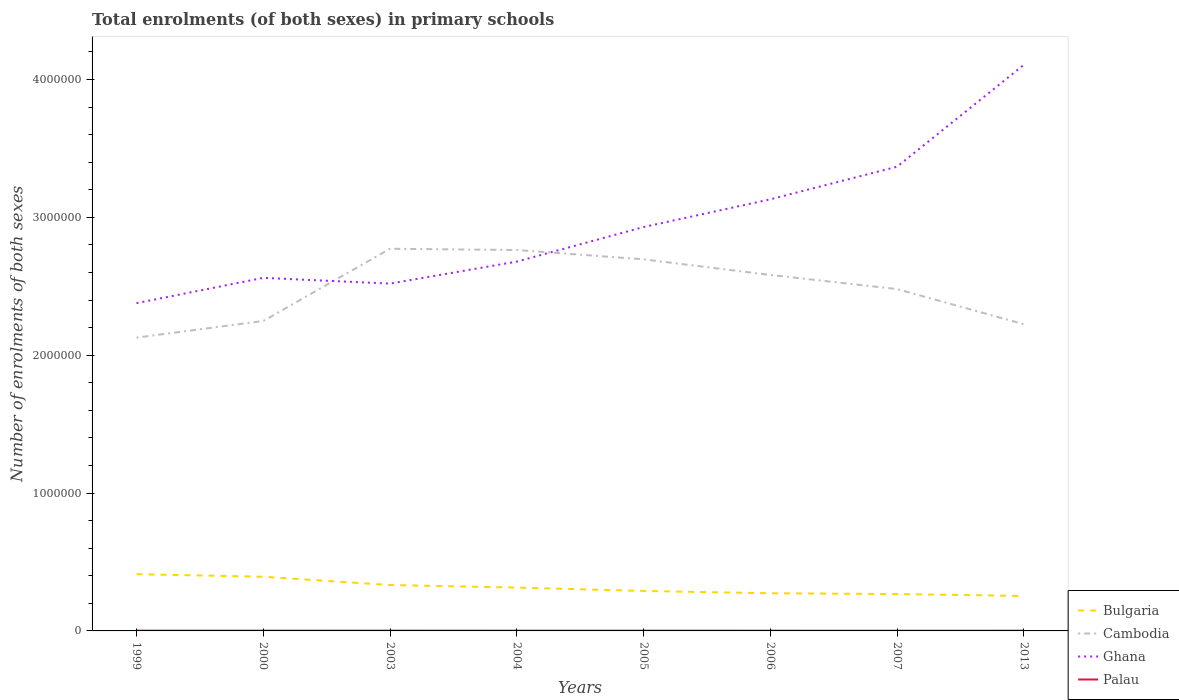Does the line corresponding to Cambodia intersect with the line corresponding to Palau?
Your answer should be very brief. No. Across all years, what is the maximum number of enrolments in primary schools in Ghana?
Make the answer very short. 2.38e+06. What is the total number of enrolments in primary schools in Cambodia in the graph?
Provide a succinct answer. 2.16e+05. What is the difference between the highest and the second highest number of enrolments in primary schools in Bulgaria?
Make the answer very short. 1.58e+05. Is the number of enrolments in primary schools in Cambodia strictly greater than the number of enrolments in primary schools in Bulgaria over the years?
Give a very brief answer. No. How many years are there in the graph?
Your response must be concise. 8. What is the difference between two consecutive major ticks on the Y-axis?
Offer a very short reply. 1.00e+06. Are the values on the major ticks of Y-axis written in scientific E-notation?
Give a very brief answer. No. What is the title of the graph?
Your answer should be compact. Total enrolments (of both sexes) in primary schools. What is the label or title of the Y-axis?
Your answer should be very brief. Number of enrolments of both sexes. What is the Number of enrolments of both sexes of Bulgaria in 1999?
Ensure brevity in your answer.  4.12e+05. What is the Number of enrolments of both sexes of Cambodia in 1999?
Your answer should be very brief. 2.13e+06. What is the Number of enrolments of both sexes in Ghana in 1999?
Your answer should be compact. 2.38e+06. What is the Number of enrolments of both sexes in Palau in 1999?
Give a very brief answer. 1901. What is the Number of enrolments of both sexes of Bulgaria in 2000?
Ensure brevity in your answer.  3.93e+05. What is the Number of enrolments of both sexes of Cambodia in 2000?
Offer a very short reply. 2.25e+06. What is the Number of enrolments of both sexes of Ghana in 2000?
Your response must be concise. 2.56e+06. What is the Number of enrolments of both sexes of Palau in 2000?
Your answer should be compact. 1942. What is the Number of enrolments of both sexes of Bulgaria in 2003?
Make the answer very short. 3.33e+05. What is the Number of enrolments of both sexes in Cambodia in 2003?
Give a very brief answer. 2.77e+06. What is the Number of enrolments of both sexes in Ghana in 2003?
Keep it short and to the point. 2.52e+06. What is the Number of enrolments of both sexes of Palau in 2003?
Provide a succinct answer. 1985. What is the Number of enrolments of both sexes in Bulgaria in 2004?
Keep it short and to the point. 3.14e+05. What is the Number of enrolments of both sexes of Cambodia in 2004?
Keep it short and to the point. 2.76e+06. What is the Number of enrolments of both sexes of Ghana in 2004?
Ensure brevity in your answer.  2.68e+06. What is the Number of enrolments of both sexes in Palau in 2004?
Provide a short and direct response. 1855. What is the Number of enrolments of both sexes of Bulgaria in 2005?
Provide a succinct answer. 2.90e+05. What is the Number of enrolments of both sexes of Cambodia in 2005?
Make the answer very short. 2.70e+06. What is the Number of enrolments of both sexes in Ghana in 2005?
Ensure brevity in your answer.  2.93e+06. What is the Number of enrolments of both sexes in Palau in 2005?
Make the answer very short. 1805. What is the Number of enrolments of both sexes of Bulgaria in 2006?
Your response must be concise. 2.73e+05. What is the Number of enrolments of both sexes of Cambodia in 2006?
Ensure brevity in your answer.  2.58e+06. What is the Number of enrolments of both sexes in Ghana in 2006?
Provide a short and direct response. 3.13e+06. What is the Number of enrolments of both sexes in Palau in 2006?
Your answer should be very brief. 1657. What is the Number of enrolments of both sexes of Bulgaria in 2007?
Your response must be concise. 2.68e+05. What is the Number of enrolments of both sexes in Cambodia in 2007?
Your answer should be compact. 2.48e+06. What is the Number of enrolments of both sexes of Ghana in 2007?
Your answer should be very brief. 3.37e+06. What is the Number of enrolments of both sexes of Palau in 2007?
Give a very brief answer. 1544. What is the Number of enrolments of both sexes in Bulgaria in 2013?
Ensure brevity in your answer.  2.54e+05. What is the Number of enrolments of both sexes of Cambodia in 2013?
Your answer should be compact. 2.22e+06. What is the Number of enrolments of both sexes in Ghana in 2013?
Your answer should be compact. 4.11e+06. What is the Number of enrolments of both sexes of Palau in 2013?
Your answer should be very brief. 1654. Across all years, what is the maximum Number of enrolments of both sexes in Bulgaria?
Provide a succinct answer. 4.12e+05. Across all years, what is the maximum Number of enrolments of both sexes in Cambodia?
Offer a very short reply. 2.77e+06. Across all years, what is the maximum Number of enrolments of both sexes of Ghana?
Your answer should be compact. 4.11e+06. Across all years, what is the maximum Number of enrolments of both sexes in Palau?
Offer a very short reply. 1985. Across all years, what is the minimum Number of enrolments of both sexes in Bulgaria?
Give a very brief answer. 2.54e+05. Across all years, what is the minimum Number of enrolments of both sexes of Cambodia?
Your response must be concise. 2.13e+06. Across all years, what is the minimum Number of enrolments of both sexes in Ghana?
Keep it short and to the point. 2.38e+06. Across all years, what is the minimum Number of enrolments of both sexes in Palau?
Offer a terse response. 1544. What is the total Number of enrolments of both sexes of Bulgaria in the graph?
Provide a short and direct response. 2.54e+06. What is the total Number of enrolments of both sexes in Cambodia in the graph?
Keep it short and to the point. 1.99e+07. What is the total Number of enrolments of both sexes of Ghana in the graph?
Provide a succinct answer. 2.37e+07. What is the total Number of enrolments of both sexes in Palau in the graph?
Give a very brief answer. 1.43e+04. What is the difference between the Number of enrolments of both sexes of Bulgaria in 1999 and that in 2000?
Offer a terse response. 1.88e+04. What is the difference between the Number of enrolments of both sexes in Cambodia in 1999 and that in 2000?
Your response must be concise. -1.21e+05. What is the difference between the Number of enrolments of both sexes in Ghana in 1999 and that in 2000?
Keep it short and to the point. -1.83e+05. What is the difference between the Number of enrolments of both sexes of Palau in 1999 and that in 2000?
Keep it short and to the point. -41. What is the difference between the Number of enrolments of both sexes of Bulgaria in 1999 and that in 2003?
Provide a succinct answer. 7.87e+04. What is the difference between the Number of enrolments of both sexes in Cambodia in 1999 and that in 2003?
Offer a very short reply. -6.45e+05. What is the difference between the Number of enrolments of both sexes in Ghana in 1999 and that in 2003?
Offer a very short reply. -1.42e+05. What is the difference between the Number of enrolments of both sexes of Palau in 1999 and that in 2003?
Give a very brief answer. -84. What is the difference between the Number of enrolments of both sexes in Bulgaria in 1999 and that in 2004?
Offer a very short reply. 9.75e+04. What is the difference between the Number of enrolments of both sexes of Cambodia in 1999 and that in 2004?
Offer a terse response. -6.35e+05. What is the difference between the Number of enrolments of both sexes in Ghana in 1999 and that in 2004?
Your answer should be compact. -3.01e+05. What is the difference between the Number of enrolments of both sexes of Bulgaria in 1999 and that in 2005?
Offer a very short reply. 1.22e+05. What is the difference between the Number of enrolments of both sexes in Cambodia in 1999 and that in 2005?
Keep it short and to the point. -5.68e+05. What is the difference between the Number of enrolments of both sexes in Ghana in 1999 and that in 2005?
Keep it short and to the point. -5.52e+05. What is the difference between the Number of enrolments of both sexes of Palau in 1999 and that in 2005?
Provide a short and direct response. 96. What is the difference between the Number of enrolments of both sexes of Bulgaria in 1999 and that in 2006?
Ensure brevity in your answer.  1.39e+05. What is the difference between the Number of enrolments of both sexes of Cambodia in 1999 and that in 2006?
Your answer should be very brief. -4.55e+05. What is the difference between the Number of enrolments of both sexes in Ghana in 1999 and that in 2006?
Ensure brevity in your answer.  -7.53e+05. What is the difference between the Number of enrolments of both sexes in Palau in 1999 and that in 2006?
Offer a terse response. 244. What is the difference between the Number of enrolments of both sexes of Bulgaria in 1999 and that in 2007?
Ensure brevity in your answer.  1.44e+05. What is the difference between the Number of enrolments of both sexes of Cambodia in 1999 and that in 2007?
Your answer should be compact. -3.52e+05. What is the difference between the Number of enrolments of both sexes in Ghana in 1999 and that in 2007?
Provide a succinct answer. -9.90e+05. What is the difference between the Number of enrolments of both sexes in Palau in 1999 and that in 2007?
Keep it short and to the point. 357. What is the difference between the Number of enrolments of both sexes of Bulgaria in 1999 and that in 2013?
Keep it short and to the point. 1.58e+05. What is the difference between the Number of enrolments of both sexes in Cambodia in 1999 and that in 2013?
Keep it short and to the point. -9.75e+04. What is the difference between the Number of enrolments of both sexes of Ghana in 1999 and that in 2013?
Ensure brevity in your answer.  -1.73e+06. What is the difference between the Number of enrolments of both sexes of Palau in 1999 and that in 2013?
Your answer should be very brief. 247. What is the difference between the Number of enrolments of both sexes in Bulgaria in 2000 and that in 2003?
Offer a terse response. 5.99e+04. What is the difference between the Number of enrolments of both sexes of Cambodia in 2000 and that in 2003?
Offer a very short reply. -5.24e+05. What is the difference between the Number of enrolments of both sexes in Ghana in 2000 and that in 2003?
Provide a succinct answer. 4.16e+04. What is the difference between the Number of enrolments of both sexes of Palau in 2000 and that in 2003?
Ensure brevity in your answer.  -43. What is the difference between the Number of enrolments of both sexes of Bulgaria in 2000 and that in 2004?
Keep it short and to the point. 7.87e+04. What is the difference between the Number of enrolments of both sexes in Cambodia in 2000 and that in 2004?
Keep it short and to the point. -5.15e+05. What is the difference between the Number of enrolments of both sexes in Ghana in 2000 and that in 2004?
Make the answer very short. -1.18e+05. What is the difference between the Number of enrolments of both sexes of Bulgaria in 2000 and that in 2005?
Give a very brief answer. 1.03e+05. What is the difference between the Number of enrolments of both sexes in Cambodia in 2000 and that in 2005?
Your response must be concise. -4.47e+05. What is the difference between the Number of enrolments of both sexes of Ghana in 2000 and that in 2005?
Your answer should be very brief. -3.69e+05. What is the difference between the Number of enrolments of both sexes in Palau in 2000 and that in 2005?
Offer a very short reply. 137. What is the difference between the Number of enrolments of both sexes of Bulgaria in 2000 and that in 2006?
Your answer should be very brief. 1.20e+05. What is the difference between the Number of enrolments of both sexes in Cambodia in 2000 and that in 2006?
Offer a very short reply. -3.34e+05. What is the difference between the Number of enrolments of both sexes of Ghana in 2000 and that in 2006?
Offer a terse response. -5.70e+05. What is the difference between the Number of enrolments of both sexes of Palau in 2000 and that in 2006?
Offer a terse response. 285. What is the difference between the Number of enrolments of both sexes in Bulgaria in 2000 and that in 2007?
Ensure brevity in your answer.  1.25e+05. What is the difference between the Number of enrolments of both sexes of Cambodia in 2000 and that in 2007?
Your answer should be compact. -2.32e+05. What is the difference between the Number of enrolments of both sexes of Ghana in 2000 and that in 2007?
Your answer should be very brief. -8.06e+05. What is the difference between the Number of enrolments of both sexes in Palau in 2000 and that in 2007?
Ensure brevity in your answer.  398. What is the difference between the Number of enrolments of both sexes in Bulgaria in 2000 and that in 2013?
Offer a very short reply. 1.39e+05. What is the difference between the Number of enrolments of both sexes in Cambodia in 2000 and that in 2013?
Provide a succinct answer. 2.32e+04. What is the difference between the Number of enrolments of both sexes in Ghana in 2000 and that in 2013?
Keep it short and to the point. -1.55e+06. What is the difference between the Number of enrolments of both sexes of Palau in 2000 and that in 2013?
Your answer should be compact. 288. What is the difference between the Number of enrolments of both sexes of Bulgaria in 2003 and that in 2004?
Give a very brief answer. 1.88e+04. What is the difference between the Number of enrolments of both sexes of Cambodia in 2003 and that in 2004?
Your answer should be very brief. 9231. What is the difference between the Number of enrolments of both sexes of Ghana in 2003 and that in 2004?
Keep it short and to the point. -1.60e+05. What is the difference between the Number of enrolments of both sexes of Palau in 2003 and that in 2004?
Give a very brief answer. 130. What is the difference between the Number of enrolments of both sexes in Bulgaria in 2003 and that in 2005?
Give a very brief answer. 4.30e+04. What is the difference between the Number of enrolments of both sexes of Cambodia in 2003 and that in 2005?
Make the answer very short. 7.67e+04. What is the difference between the Number of enrolments of both sexes in Ghana in 2003 and that in 2005?
Ensure brevity in your answer.  -4.10e+05. What is the difference between the Number of enrolments of both sexes in Palau in 2003 and that in 2005?
Offer a terse response. 180. What is the difference between the Number of enrolments of both sexes in Bulgaria in 2003 and that in 2006?
Offer a terse response. 6.00e+04. What is the difference between the Number of enrolments of both sexes of Cambodia in 2003 and that in 2006?
Keep it short and to the point. 1.90e+05. What is the difference between the Number of enrolments of both sexes of Ghana in 2003 and that in 2006?
Your response must be concise. -6.11e+05. What is the difference between the Number of enrolments of both sexes in Palau in 2003 and that in 2006?
Your response must be concise. 328. What is the difference between the Number of enrolments of both sexes of Bulgaria in 2003 and that in 2007?
Ensure brevity in your answer.  6.54e+04. What is the difference between the Number of enrolments of both sexes of Cambodia in 2003 and that in 2007?
Ensure brevity in your answer.  2.92e+05. What is the difference between the Number of enrolments of both sexes of Ghana in 2003 and that in 2007?
Provide a succinct answer. -8.48e+05. What is the difference between the Number of enrolments of both sexes in Palau in 2003 and that in 2007?
Offer a terse response. 441. What is the difference between the Number of enrolments of both sexes of Bulgaria in 2003 and that in 2013?
Ensure brevity in your answer.  7.93e+04. What is the difference between the Number of enrolments of both sexes of Cambodia in 2003 and that in 2013?
Offer a terse response. 5.47e+05. What is the difference between the Number of enrolments of both sexes in Ghana in 2003 and that in 2013?
Ensure brevity in your answer.  -1.59e+06. What is the difference between the Number of enrolments of both sexes of Palau in 2003 and that in 2013?
Your answer should be compact. 331. What is the difference between the Number of enrolments of both sexes of Bulgaria in 2004 and that in 2005?
Offer a terse response. 2.42e+04. What is the difference between the Number of enrolments of both sexes of Cambodia in 2004 and that in 2005?
Your answer should be compact. 6.75e+04. What is the difference between the Number of enrolments of both sexes of Ghana in 2004 and that in 2005?
Provide a short and direct response. -2.51e+05. What is the difference between the Number of enrolments of both sexes of Bulgaria in 2004 and that in 2006?
Your answer should be compact. 4.12e+04. What is the difference between the Number of enrolments of both sexes in Cambodia in 2004 and that in 2006?
Give a very brief answer. 1.81e+05. What is the difference between the Number of enrolments of both sexes of Ghana in 2004 and that in 2006?
Provide a short and direct response. -4.52e+05. What is the difference between the Number of enrolments of both sexes of Palau in 2004 and that in 2006?
Offer a very short reply. 198. What is the difference between the Number of enrolments of both sexes in Bulgaria in 2004 and that in 2007?
Offer a very short reply. 4.66e+04. What is the difference between the Number of enrolments of both sexes of Cambodia in 2004 and that in 2007?
Provide a succinct answer. 2.83e+05. What is the difference between the Number of enrolments of both sexes in Ghana in 2004 and that in 2007?
Keep it short and to the point. -6.88e+05. What is the difference between the Number of enrolments of both sexes of Palau in 2004 and that in 2007?
Offer a very short reply. 311. What is the difference between the Number of enrolments of both sexes of Bulgaria in 2004 and that in 2013?
Keep it short and to the point. 6.05e+04. What is the difference between the Number of enrolments of both sexes in Cambodia in 2004 and that in 2013?
Ensure brevity in your answer.  5.38e+05. What is the difference between the Number of enrolments of both sexes in Ghana in 2004 and that in 2013?
Provide a succinct answer. -1.43e+06. What is the difference between the Number of enrolments of both sexes in Palau in 2004 and that in 2013?
Keep it short and to the point. 201. What is the difference between the Number of enrolments of both sexes of Bulgaria in 2005 and that in 2006?
Provide a short and direct response. 1.70e+04. What is the difference between the Number of enrolments of both sexes of Cambodia in 2005 and that in 2006?
Offer a very short reply. 1.13e+05. What is the difference between the Number of enrolments of both sexes of Ghana in 2005 and that in 2006?
Provide a succinct answer. -2.01e+05. What is the difference between the Number of enrolments of both sexes in Palau in 2005 and that in 2006?
Your answer should be compact. 148. What is the difference between the Number of enrolments of both sexes in Bulgaria in 2005 and that in 2007?
Offer a terse response. 2.24e+04. What is the difference between the Number of enrolments of both sexes of Cambodia in 2005 and that in 2007?
Your response must be concise. 2.16e+05. What is the difference between the Number of enrolments of both sexes in Ghana in 2005 and that in 2007?
Your answer should be compact. -4.38e+05. What is the difference between the Number of enrolments of both sexes of Palau in 2005 and that in 2007?
Provide a succinct answer. 261. What is the difference between the Number of enrolments of both sexes of Bulgaria in 2005 and that in 2013?
Give a very brief answer. 3.63e+04. What is the difference between the Number of enrolments of both sexes of Cambodia in 2005 and that in 2013?
Keep it short and to the point. 4.70e+05. What is the difference between the Number of enrolments of both sexes in Ghana in 2005 and that in 2013?
Your answer should be compact. -1.18e+06. What is the difference between the Number of enrolments of both sexes of Palau in 2005 and that in 2013?
Make the answer very short. 151. What is the difference between the Number of enrolments of both sexes in Bulgaria in 2006 and that in 2007?
Ensure brevity in your answer.  5461. What is the difference between the Number of enrolments of both sexes in Cambodia in 2006 and that in 2007?
Your response must be concise. 1.03e+05. What is the difference between the Number of enrolments of both sexes of Ghana in 2006 and that in 2007?
Make the answer very short. -2.37e+05. What is the difference between the Number of enrolments of both sexes in Palau in 2006 and that in 2007?
Your answer should be very brief. 113. What is the difference between the Number of enrolments of both sexes in Bulgaria in 2006 and that in 2013?
Keep it short and to the point. 1.94e+04. What is the difference between the Number of enrolments of both sexes of Cambodia in 2006 and that in 2013?
Give a very brief answer. 3.57e+05. What is the difference between the Number of enrolments of both sexes of Ghana in 2006 and that in 2013?
Your response must be concise. -9.75e+05. What is the difference between the Number of enrolments of both sexes of Bulgaria in 2007 and that in 2013?
Your answer should be compact. 1.39e+04. What is the difference between the Number of enrolments of both sexes of Cambodia in 2007 and that in 2013?
Offer a very short reply. 2.55e+05. What is the difference between the Number of enrolments of both sexes in Ghana in 2007 and that in 2013?
Your answer should be compact. -7.39e+05. What is the difference between the Number of enrolments of both sexes of Palau in 2007 and that in 2013?
Keep it short and to the point. -110. What is the difference between the Number of enrolments of both sexes in Bulgaria in 1999 and the Number of enrolments of both sexes in Cambodia in 2000?
Give a very brief answer. -1.84e+06. What is the difference between the Number of enrolments of both sexes in Bulgaria in 1999 and the Number of enrolments of both sexes in Ghana in 2000?
Your answer should be very brief. -2.15e+06. What is the difference between the Number of enrolments of both sexes in Bulgaria in 1999 and the Number of enrolments of both sexes in Palau in 2000?
Make the answer very short. 4.10e+05. What is the difference between the Number of enrolments of both sexes of Cambodia in 1999 and the Number of enrolments of both sexes of Ghana in 2000?
Ensure brevity in your answer.  -4.33e+05. What is the difference between the Number of enrolments of both sexes in Cambodia in 1999 and the Number of enrolments of both sexes in Palau in 2000?
Offer a terse response. 2.13e+06. What is the difference between the Number of enrolments of both sexes of Ghana in 1999 and the Number of enrolments of both sexes of Palau in 2000?
Provide a short and direct response. 2.38e+06. What is the difference between the Number of enrolments of both sexes of Bulgaria in 1999 and the Number of enrolments of both sexes of Cambodia in 2003?
Your answer should be very brief. -2.36e+06. What is the difference between the Number of enrolments of both sexes of Bulgaria in 1999 and the Number of enrolments of both sexes of Ghana in 2003?
Your response must be concise. -2.11e+06. What is the difference between the Number of enrolments of both sexes of Bulgaria in 1999 and the Number of enrolments of both sexes of Palau in 2003?
Provide a short and direct response. 4.10e+05. What is the difference between the Number of enrolments of both sexes in Cambodia in 1999 and the Number of enrolments of both sexes in Ghana in 2003?
Offer a very short reply. -3.92e+05. What is the difference between the Number of enrolments of both sexes in Cambodia in 1999 and the Number of enrolments of both sexes in Palau in 2003?
Provide a succinct answer. 2.13e+06. What is the difference between the Number of enrolments of both sexes of Ghana in 1999 and the Number of enrolments of both sexes of Palau in 2003?
Your answer should be compact. 2.38e+06. What is the difference between the Number of enrolments of both sexes in Bulgaria in 1999 and the Number of enrolments of both sexes in Cambodia in 2004?
Make the answer very short. -2.35e+06. What is the difference between the Number of enrolments of both sexes in Bulgaria in 1999 and the Number of enrolments of both sexes in Ghana in 2004?
Provide a succinct answer. -2.27e+06. What is the difference between the Number of enrolments of both sexes of Bulgaria in 1999 and the Number of enrolments of both sexes of Palau in 2004?
Your answer should be very brief. 4.10e+05. What is the difference between the Number of enrolments of both sexes of Cambodia in 1999 and the Number of enrolments of both sexes of Ghana in 2004?
Make the answer very short. -5.51e+05. What is the difference between the Number of enrolments of both sexes in Cambodia in 1999 and the Number of enrolments of both sexes in Palau in 2004?
Provide a short and direct response. 2.13e+06. What is the difference between the Number of enrolments of both sexes in Ghana in 1999 and the Number of enrolments of both sexes in Palau in 2004?
Keep it short and to the point. 2.38e+06. What is the difference between the Number of enrolments of both sexes in Bulgaria in 1999 and the Number of enrolments of both sexes in Cambodia in 2005?
Your response must be concise. -2.28e+06. What is the difference between the Number of enrolments of both sexes in Bulgaria in 1999 and the Number of enrolments of both sexes in Ghana in 2005?
Provide a short and direct response. -2.52e+06. What is the difference between the Number of enrolments of both sexes of Bulgaria in 1999 and the Number of enrolments of both sexes of Palau in 2005?
Give a very brief answer. 4.10e+05. What is the difference between the Number of enrolments of both sexes of Cambodia in 1999 and the Number of enrolments of both sexes of Ghana in 2005?
Your answer should be very brief. -8.02e+05. What is the difference between the Number of enrolments of both sexes in Cambodia in 1999 and the Number of enrolments of both sexes in Palau in 2005?
Keep it short and to the point. 2.13e+06. What is the difference between the Number of enrolments of both sexes of Ghana in 1999 and the Number of enrolments of both sexes of Palau in 2005?
Give a very brief answer. 2.38e+06. What is the difference between the Number of enrolments of both sexes in Bulgaria in 1999 and the Number of enrolments of both sexes in Cambodia in 2006?
Offer a very short reply. -2.17e+06. What is the difference between the Number of enrolments of both sexes in Bulgaria in 1999 and the Number of enrolments of both sexes in Ghana in 2006?
Provide a succinct answer. -2.72e+06. What is the difference between the Number of enrolments of both sexes in Bulgaria in 1999 and the Number of enrolments of both sexes in Palau in 2006?
Provide a short and direct response. 4.10e+05. What is the difference between the Number of enrolments of both sexes in Cambodia in 1999 and the Number of enrolments of both sexes in Ghana in 2006?
Your answer should be very brief. -1.00e+06. What is the difference between the Number of enrolments of both sexes of Cambodia in 1999 and the Number of enrolments of both sexes of Palau in 2006?
Make the answer very short. 2.13e+06. What is the difference between the Number of enrolments of both sexes of Ghana in 1999 and the Number of enrolments of both sexes of Palau in 2006?
Make the answer very short. 2.38e+06. What is the difference between the Number of enrolments of both sexes in Bulgaria in 1999 and the Number of enrolments of both sexes in Cambodia in 2007?
Your answer should be compact. -2.07e+06. What is the difference between the Number of enrolments of both sexes of Bulgaria in 1999 and the Number of enrolments of both sexes of Ghana in 2007?
Provide a short and direct response. -2.96e+06. What is the difference between the Number of enrolments of both sexes in Bulgaria in 1999 and the Number of enrolments of both sexes in Palau in 2007?
Ensure brevity in your answer.  4.10e+05. What is the difference between the Number of enrolments of both sexes in Cambodia in 1999 and the Number of enrolments of both sexes in Ghana in 2007?
Your response must be concise. -1.24e+06. What is the difference between the Number of enrolments of both sexes in Cambodia in 1999 and the Number of enrolments of both sexes in Palau in 2007?
Your response must be concise. 2.13e+06. What is the difference between the Number of enrolments of both sexes in Ghana in 1999 and the Number of enrolments of both sexes in Palau in 2007?
Ensure brevity in your answer.  2.38e+06. What is the difference between the Number of enrolments of both sexes of Bulgaria in 1999 and the Number of enrolments of both sexes of Cambodia in 2013?
Your answer should be very brief. -1.81e+06. What is the difference between the Number of enrolments of both sexes of Bulgaria in 1999 and the Number of enrolments of both sexes of Ghana in 2013?
Provide a short and direct response. -3.69e+06. What is the difference between the Number of enrolments of both sexes in Bulgaria in 1999 and the Number of enrolments of both sexes in Palau in 2013?
Provide a short and direct response. 4.10e+05. What is the difference between the Number of enrolments of both sexes of Cambodia in 1999 and the Number of enrolments of both sexes of Ghana in 2013?
Your response must be concise. -1.98e+06. What is the difference between the Number of enrolments of both sexes in Cambodia in 1999 and the Number of enrolments of both sexes in Palau in 2013?
Keep it short and to the point. 2.13e+06. What is the difference between the Number of enrolments of both sexes of Ghana in 1999 and the Number of enrolments of both sexes of Palau in 2013?
Give a very brief answer. 2.38e+06. What is the difference between the Number of enrolments of both sexes in Bulgaria in 2000 and the Number of enrolments of both sexes in Cambodia in 2003?
Offer a very short reply. -2.38e+06. What is the difference between the Number of enrolments of both sexes in Bulgaria in 2000 and the Number of enrolments of both sexes in Ghana in 2003?
Give a very brief answer. -2.13e+06. What is the difference between the Number of enrolments of both sexes in Bulgaria in 2000 and the Number of enrolments of both sexes in Palau in 2003?
Ensure brevity in your answer.  3.91e+05. What is the difference between the Number of enrolments of both sexes in Cambodia in 2000 and the Number of enrolments of both sexes in Ghana in 2003?
Offer a very short reply. -2.71e+05. What is the difference between the Number of enrolments of both sexes of Cambodia in 2000 and the Number of enrolments of both sexes of Palau in 2003?
Make the answer very short. 2.25e+06. What is the difference between the Number of enrolments of both sexes of Ghana in 2000 and the Number of enrolments of both sexes of Palau in 2003?
Your response must be concise. 2.56e+06. What is the difference between the Number of enrolments of both sexes in Bulgaria in 2000 and the Number of enrolments of both sexes in Cambodia in 2004?
Provide a succinct answer. -2.37e+06. What is the difference between the Number of enrolments of both sexes of Bulgaria in 2000 and the Number of enrolments of both sexes of Ghana in 2004?
Ensure brevity in your answer.  -2.29e+06. What is the difference between the Number of enrolments of both sexes in Bulgaria in 2000 and the Number of enrolments of both sexes in Palau in 2004?
Your response must be concise. 3.91e+05. What is the difference between the Number of enrolments of both sexes in Cambodia in 2000 and the Number of enrolments of both sexes in Ghana in 2004?
Offer a terse response. -4.31e+05. What is the difference between the Number of enrolments of both sexes of Cambodia in 2000 and the Number of enrolments of both sexes of Palau in 2004?
Keep it short and to the point. 2.25e+06. What is the difference between the Number of enrolments of both sexes of Ghana in 2000 and the Number of enrolments of both sexes of Palau in 2004?
Your response must be concise. 2.56e+06. What is the difference between the Number of enrolments of both sexes in Bulgaria in 2000 and the Number of enrolments of both sexes in Cambodia in 2005?
Keep it short and to the point. -2.30e+06. What is the difference between the Number of enrolments of both sexes of Bulgaria in 2000 and the Number of enrolments of both sexes of Ghana in 2005?
Offer a terse response. -2.54e+06. What is the difference between the Number of enrolments of both sexes of Bulgaria in 2000 and the Number of enrolments of both sexes of Palau in 2005?
Make the answer very short. 3.91e+05. What is the difference between the Number of enrolments of both sexes in Cambodia in 2000 and the Number of enrolments of both sexes in Ghana in 2005?
Provide a succinct answer. -6.81e+05. What is the difference between the Number of enrolments of both sexes of Cambodia in 2000 and the Number of enrolments of both sexes of Palau in 2005?
Your response must be concise. 2.25e+06. What is the difference between the Number of enrolments of both sexes of Ghana in 2000 and the Number of enrolments of both sexes of Palau in 2005?
Your answer should be compact. 2.56e+06. What is the difference between the Number of enrolments of both sexes in Bulgaria in 2000 and the Number of enrolments of both sexes in Cambodia in 2006?
Give a very brief answer. -2.19e+06. What is the difference between the Number of enrolments of both sexes of Bulgaria in 2000 and the Number of enrolments of both sexes of Ghana in 2006?
Your answer should be very brief. -2.74e+06. What is the difference between the Number of enrolments of both sexes of Bulgaria in 2000 and the Number of enrolments of both sexes of Palau in 2006?
Give a very brief answer. 3.91e+05. What is the difference between the Number of enrolments of both sexes of Cambodia in 2000 and the Number of enrolments of both sexes of Ghana in 2006?
Provide a succinct answer. -8.82e+05. What is the difference between the Number of enrolments of both sexes in Cambodia in 2000 and the Number of enrolments of both sexes in Palau in 2006?
Offer a terse response. 2.25e+06. What is the difference between the Number of enrolments of both sexes in Ghana in 2000 and the Number of enrolments of both sexes in Palau in 2006?
Provide a short and direct response. 2.56e+06. What is the difference between the Number of enrolments of both sexes in Bulgaria in 2000 and the Number of enrolments of both sexes in Cambodia in 2007?
Keep it short and to the point. -2.09e+06. What is the difference between the Number of enrolments of both sexes of Bulgaria in 2000 and the Number of enrolments of both sexes of Ghana in 2007?
Make the answer very short. -2.97e+06. What is the difference between the Number of enrolments of both sexes in Bulgaria in 2000 and the Number of enrolments of both sexes in Palau in 2007?
Provide a succinct answer. 3.91e+05. What is the difference between the Number of enrolments of both sexes of Cambodia in 2000 and the Number of enrolments of both sexes of Ghana in 2007?
Your answer should be compact. -1.12e+06. What is the difference between the Number of enrolments of both sexes in Cambodia in 2000 and the Number of enrolments of both sexes in Palau in 2007?
Provide a succinct answer. 2.25e+06. What is the difference between the Number of enrolments of both sexes in Ghana in 2000 and the Number of enrolments of both sexes in Palau in 2007?
Make the answer very short. 2.56e+06. What is the difference between the Number of enrolments of both sexes in Bulgaria in 2000 and the Number of enrolments of both sexes in Cambodia in 2013?
Keep it short and to the point. -1.83e+06. What is the difference between the Number of enrolments of both sexes of Bulgaria in 2000 and the Number of enrolments of both sexes of Ghana in 2013?
Your response must be concise. -3.71e+06. What is the difference between the Number of enrolments of both sexes of Bulgaria in 2000 and the Number of enrolments of both sexes of Palau in 2013?
Ensure brevity in your answer.  3.91e+05. What is the difference between the Number of enrolments of both sexes in Cambodia in 2000 and the Number of enrolments of both sexes in Ghana in 2013?
Keep it short and to the point. -1.86e+06. What is the difference between the Number of enrolments of both sexes in Cambodia in 2000 and the Number of enrolments of both sexes in Palau in 2013?
Give a very brief answer. 2.25e+06. What is the difference between the Number of enrolments of both sexes in Ghana in 2000 and the Number of enrolments of both sexes in Palau in 2013?
Keep it short and to the point. 2.56e+06. What is the difference between the Number of enrolments of both sexes of Bulgaria in 2003 and the Number of enrolments of both sexes of Cambodia in 2004?
Your response must be concise. -2.43e+06. What is the difference between the Number of enrolments of both sexes of Bulgaria in 2003 and the Number of enrolments of both sexes of Ghana in 2004?
Your response must be concise. -2.35e+06. What is the difference between the Number of enrolments of both sexes of Bulgaria in 2003 and the Number of enrolments of both sexes of Palau in 2004?
Your answer should be very brief. 3.31e+05. What is the difference between the Number of enrolments of both sexes of Cambodia in 2003 and the Number of enrolments of both sexes of Ghana in 2004?
Make the answer very short. 9.32e+04. What is the difference between the Number of enrolments of both sexes of Cambodia in 2003 and the Number of enrolments of both sexes of Palau in 2004?
Make the answer very short. 2.77e+06. What is the difference between the Number of enrolments of both sexes in Ghana in 2003 and the Number of enrolments of both sexes in Palau in 2004?
Make the answer very short. 2.52e+06. What is the difference between the Number of enrolments of both sexes of Bulgaria in 2003 and the Number of enrolments of both sexes of Cambodia in 2005?
Your response must be concise. -2.36e+06. What is the difference between the Number of enrolments of both sexes of Bulgaria in 2003 and the Number of enrolments of both sexes of Ghana in 2005?
Offer a terse response. -2.60e+06. What is the difference between the Number of enrolments of both sexes in Bulgaria in 2003 and the Number of enrolments of both sexes in Palau in 2005?
Ensure brevity in your answer.  3.31e+05. What is the difference between the Number of enrolments of both sexes in Cambodia in 2003 and the Number of enrolments of both sexes in Ghana in 2005?
Offer a very short reply. -1.57e+05. What is the difference between the Number of enrolments of both sexes in Cambodia in 2003 and the Number of enrolments of both sexes in Palau in 2005?
Make the answer very short. 2.77e+06. What is the difference between the Number of enrolments of both sexes in Ghana in 2003 and the Number of enrolments of both sexes in Palau in 2005?
Provide a succinct answer. 2.52e+06. What is the difference between the Number of enrolments of both sexes of Bulgaria in 2003 and the Number of enrolments of both sexes of Cambodia in 2006?
Provide a succinct answer. -2.25e+06. What is the difference between the Number of enrolments of both sexes in Bulgaria in 2003 and the Number of enrolments of both sexes in Ghana in 2006?
Ensure brevity in your answer.  -2.80e+06. What is the difference between the Number of enrolments of both sexes of Bulgaria in 2003 and the Number of enrolments of both sexes of Palau in 2006?
Your answer should be very brief. 3.31e+05. What is the difference between the Number of enrolments of both sexes in Cambodia in 2003 and the Number of enrolments of both sexes in Ghana in 2006?
Your response must be concise. -3.58e+05. What is the difference between the Number of enrolments of both sexes in Cambodia in 2003 and the Number of enrolments of both sexes in Palau in 2006?
Your answer should be very brief. 2.77e+06. What is the difference between the Number of enrolments of both sexes of Ghana in 2003 and the Number of enrolments of both sexes of Palau in 2006?
Provide a short and direct response. 2.52e+06. What is the difference between the Number of enrolments of both sexes in Bulgaria in 2003 and the Number of enrolments of both sexes in Cambodia in 2007?
Give a very brief answer. -2.15e+06. What is the difference between the Number of enrolments of both sexes of Bulgaria in 2003 and the Number of enrolments of both sexes of Ghana in 2007?
Your answer should be very brief. -3.03e+06. What is the difference between the Number of enrolments of both sexes of Bulgaria in 2003 and the Number of enrolments of both sexes of Palau in 2007?
Give a very brief answer. 3.31e+05. What is the difference between the Number of enrolments of both sexes in Cambodia in 2003 and the Number of enrolments of both sexes in Ghana in 2007?
Offer a very short reply. -5.95e+05. What is the difference between the Number of enrolments of both sexes of Cambodia in 2003 and the Number of enrolments of both sexes of Palau in 2007?
Offer a very short reply. 2.77e+06. What is the difference between the Number of enrolments of both sexes in Ghana in 2003 and the Number of enrolments of both sexes in Palau in 2007?
Offer a terse response. 2.52e+06. What is the difference between the Number of enrolments of both sexes in Bulgaria in 2003 and the Number of enrolments of both sexes in Cambodia in 2013?
Your answer should be compact. -1.89e+06. What is the difference between the Number of enrolments of both sexes of Bulgaria in 2003 and the Number of enrolments of both sexes of Ghana in 2013?
Provide a short and direct response. -3.77e+06. What is the difference between the Number of enrolments of both sexes in Bulgaria in 2003 and the Number of enrolments of both sexes in Palau in 2013?
Your answer should be compact. 3.31e+05. What is the difference between the Number of enrolments of both sexes of Cambodia in 2003 and the Number of enrolments of both sexes of Ghana in 2013?
Your response must be concise. -1.33e+06. What is the difference between the Number of enrolments of both sexes of Cambodia in 2003 and the Number of enrolments of both sexes of Palau in 2013?
Your response must be concise. 2.77e+06. What is the difference between the Number of enrolments of both sexes of Ghana in 2003 and the Number of enrolments of both sexes of Palau in 2013?
Provide a succinct answer. 2.52e+06. What is the difference between the Number of enrolments of both sexes in Bulgaria in 2004 and the Number of enrolments of both sexes in Cambodia in 2005?
Ensure brevity in your answer.  -2.38e+06. What is the difference between the Number of enrolments of both sexes in Bulgaria in 2004 and the Number of enrolments of both sexes in Ghana in 2005?
Provide a short and direct response. -2.62e+06. What is the difference between the Number of enrolments of both sexes in Bulgaria in 2004 and the Number of enrolments of both sexes in Palau in 2005?
Ensure brevity in your answer.  3.12e+05. What is the difference between the Number of enrolments of both sexes in Cambodia in 2004 and the Number of enrolments of both sexes in Ghana in 2005?
Give a very brief answer. -1.67e+05. What is the difference between the Number of enrolments of both sexes of Cambodia in 2004 and the Number of enrolments of both sexes of Palau in 2005?
Offer a very short reply. 2.76e+06. What is the difference between the Number of enrolments of both sexes of Ghana in 2004 and the Number of enrolments of both sexes of Palau in 2005?
Offer a very short reply. 2.68e+06. What is the difference between the Number of enrolments of both sexes in Bulgaria in 2004 and the Number of enrolments of both sexes in Cambodia in 2006?
Make the answer very short. -2.27e+06. What is the difference between the Number of enrolments of both sexes in Bulgaria in 2004 and the Number of enrolments of both sexes in Ghana in 2006?
Make the answer very short. -2.82e+06. What is the difference between the Number of enrolments of both sexes in Bulgaria in 2004 and the Number of enrolments of both sexes in Palau in 2006?
Offer a terse response. 3.13e+05. What is the difference between the Number of enrolments of both sexes of Cambodia in 2004 and the Number of enrolments of both sexes of Ghana in 2006?
Ensure brevity in your answer.  -3.68e+05. What is the difference between the Number of enrolments of both sexes in Cambodia in 2004 and the Number of enrolments of both sexes in Palau in 2006?
Provide a short and direct response. 2.76e+06. What is the difference between the Number of enrolments of both sexes of Ghana in 2004 and the Number of enrolments of both sexes of Palau in 2006?
Offer a very short reply. 2.68e+06. What is the difference between the Number of enrolments of both sexes of Bulgaria in 2004 and the Number of enrolments of both sexes of Cambodia in 2007?
Your response must be concise. -2.17e+06. What is the difference between the Number of enrolments of both sexes of Bulgaria in 2004 and the Number of enrolments of both sexes of Ghana in 2007?
Your answer should be compact. -3.05e+06. What is the difference between the Number of enrolments of both sexes in Bulgaria in 2004 and the Number of enrolments of both sexes in Palau in 2007?
Your answer should be very brief. 3.13e+05. What is the difference between the Number of enrolments of both sexes of Cambodia in 2004 and the Number of enrolments of both sexes of Ghana in 2007?
Provide a short and direct response. -6.04e+05. What is the difference between the Number of enrolments of both sexes of Cambodia in 2004 and the Number of enrolments of both sexes of Palau in 2007?
Your response must be concise. 2.76e+06. What is the difference between the Number of enrolments of both sexes of Ghana in 2004 and the Number of enrolments of both sexes of Palau in 2007?
Provide a short and direct response. 2.68e+06. What is the difference between the Number of enrolments of both sexes of Bulgaria in 2004 and the Number of enrolments of both sexes of Cambodia in 2013?
Keep it short and to the point. -1.91e+06. What is the difference between the Number of enrolments of both sexes in Bulgaria in 2004 and the Number of enrolments of both sexes in Ghana in 2013?
Offer a terse response. -3.79e+06. What is the difference between the Number of enrolments of both sexes in Bulgaria in 2004 and the Number of enrolments of both sexes in Palau in 2013?
Give a very brief answer. 3.13e+05. What is the difference between the Number of enrolments of both sexes of Cambodia in 2004 and the Number of enrolments of both sexes of Ghana in 2013?
Make the answer very short. -1.34e+06. What is the difference between the Number of enrolments of both sexes of Cambodia in 2004 and the Number of enrolments of both sexes of Palau in 2013?
Offer a very short reply. 2.76e+06. What is the difference between the Number of enrolments of both sexes in Ghana in 2004 and the Number of enrolments of both sexes in Palau in 2013?
Ensure brevity in your answer.  2.68e+06. What is the difference between the Number of enrolments of both sexes in Bulgaria in 2005 and the Number of enrolments of both sexes in Cambodia in 2006?
Provide a succinct answer. -2.29e+06. What is the difference between the Number of enrolments of both sexes in Bulgaria in 2005 and the Number of enrolments of both sexes in Ghana in 2006?
Offer a terse response. -2.84e+06. What is the difference between the Number of enrolments of both sexes of Bulgaria in 2005 and the Number of enrolments of both sexes of Palau in 2006?
Provide a succinct answer. 2.88e+05. What is the difference between the Number of enrolments of both sexes in Cambodia in 2005 and the Number of enrolments of both sexes in Ghana in 2006?
Offer a terse response. -4.35e+05. What is the difference between the Number of enrolments of both sexes in Cambodia in 2005 and the Number of enrolments of both sexes in Palau in 2006?
Ensure brevity in your answer.  2.69e+06. What is the difference between the Number of enrolments of both sexes in Ghana in 2005 and the Number of enrolments of both sexes in Palau in 2006?
Provide a succinct answer. 2.93e+06. What is the difference between the Number of enrolments of both sexes of Bulgaria in 2005 and the Number of enrolments of both sexes of Cambodia in 2007?
Keep it short and to the point. -2.19e+06. What is the difference between the Number of enrolments of both sexes of Bulgaria in 2005 and the Number of enrolments of both sexes of Ghana in 2007?
Keep it short and to the point. -3.08e+06. What is the difference between the Number of enrolments of both sexes in Bulgaria in 2005 and the Number of enrolments of both sexes in Palau in 2007?
Give a very brief answer. 2.88e+05. What is the difference between the Number of enrolments of both sexes in Cambodia in 2005 and the Number of enrolments of both sexes in Ghana in 2007?
Your answer should be very brief. -6.72e+05. What is the difference between the Number of enrolments of both sexes of Cambodia in 2005 and the Number of enrolments of both sexes of Palau in 2007?
Your answer should be very brief. 2.69e+06. What is the difference between the Number of enrolments of both sexes of Ghana in 2005 and the Number of enrolments of both sexes of Palau in 2007?
Offer a very short reply. 2.93e+06. What is the difference between the Number of enrolments of both sexes of Bulgaria in 2005 and the Number of enrolments of both sexes of Cambodia in 2013?
Your answer should be very brief. -1.93e+06. What is the difference between the Number of enrolments of both sexes in Bulgaria in 2005 and the Number of enrolments of both sexes in Ghana in 2013?
Keep it short and to the point. -3.82e+06. What is the difference between the Number of enrolments of both sexes of Bulgaria in 2005 and the Number of enrolments of both sexes of Palau in 2013?
Your answer should be compact. 2.88e+05. What is the difference between the Number of enrolments of both sexes of Cambodia in 2005 and the Number of enrolments of both sexes of Ghana in 2013?
Provide a succinct answer. -1.41e+06. What is the difference between the Number of enrolments of both sexes in Cambodia in 2005 and the Number of enrolments of both sexes in Palau in 2013?
Keep it short and to the point. 2.69e+06. What is the difference between the Number of enrolments of both sexes of Ghana in 2005 and the Number of enrolments of both sexes of Palau in 2013?
Offer a terse response. 2.93e+06. What is the difference between the Number of enrolments of both sexes in Bulgaria in 2006 and the Number of enrolments of both sexes in Cambodia in 2007?
Your response must be concise. -2.21e+06. What is the difference between the Number of enrolments of both sexes of Bulgaria in 2006 and the Number of enrolments of both sexes of Ghana in 2007?
Provide a short and direct response. -3.09e+06. What is the difference between the Number of enrolments of both sexes in Bulgaria in 2006 and the Number of enrolments of both sexes in Palau in 2007?
Your answer should be very brief. 2.72e+05. What is the difference between the Number of enrolments of both sexes in Cambodia in 2006 and the Number of enrolments of both sexes in Ghana in 2007?
Make the answer very short. -7.85e+05. What is the difference between the Number of enrolments of both sexes in Cambodia in 2006 and the Number of enrolments of both sexes in Palau in 2007?
Your response must be concise. 2.58e+06. What is the difference between the Number of enrolments of both sexes in Ghana in 2006 and the Number of enrolments of both sexes in Palau in 2007?
Your response must be concise. 3.13e+06. What is the difference between the Number of enrolments of both sexes in Bulgaria in 2006 and the Number of enrolments of both sexes in Cambodia in 2013?
Offer a terse response. -1.95e+06. What is the difference between the Number of enrolments of both sexes of Bulgaria in 2006 and the Number of enrolments of both sexes of Ghana in 2013?
Keep it short and to the point. -3.83e+06. What is the difference between the Number of enrolments of both sexes in Bulgaria in 2006 and the Number of enrolments of both sexes in Palau in 2013?
Your answer should be compact. 2.71e+05. What is the difference between the Number of enrolments of both sexes of Cambodia in 2006 and the Number of enrolments of both sexes of Ghana in 2013?
Your answer should be very brief. -1.52e+06. What is the difference between the Number of enrolments of both sexes in Cambodia in 2006 and the Number of enrolments of both sexes in Palau in 2013?
Offer a very short reply. 2.58e+06. What is the difference between the Number of enrolments of both sexes in Ghana in 2006 and the Number of enrolments of both sexes in Palau in 2013?
Your answer should be very brief. 3.13e+06. What is the difference between the Number of enrolments of both sexes of Bulgaria in 2007 and the Number of enrolments of both sexes of Cambodia in 2013?
Your answer should be very brief. -1.96e+06. What is the difference between the Number of enrolments of both sexes of Bulgaria in 2007 and the Number of enrolments of both sexes of Ghana in 2013?
Offer a terse response. -3.84e+06. What is the difference between the Number of enrolments of both sexes in Bulgaria in 2007 and the Number of enrolments of both sexes in Palau in 2013?
Make the answer very short. 2.66e+05. What is the difference between the Number of enrolments of both sexes in Cambodia in 2007 and the Number of enrolments of both sexes in Ghana in 2013?
Your answer should be very brief. -1.63e+06. What is the difference between the Number of enrolments of both sexes of Cambodia in 2007 and the Number of enrolments of both sexes of Palau in 2013?
Offer a very short reply. 2.48e+06. What is the difference between the Number of enrolments of both sexes in Ghana in 2007 and the Number of enrolments of both sexes in Palau in 2013?
Ensure brevity in your answer.  3.37e+06. What is the average Number of enrolments of both sexes in Bulgaria per year?
Offer a terse response. 3.17e+05. What is the average Number of enrolments of both sexes in Cambodia per year?
Ensure brevity in your answer.  2.49e+06. What is the average Number of enrolments of both sexes in Ghana per year?
Your response must be concise. 2.96e+06. What is the average Number of enrolments of both sexes of Palau per year?
Provide a short and direct response. 1792.88. In the year 1999, what is the difference between the Number of enrolments of both sexes in Bulgaria and Number of enrolments of both sexes in Cambodia?
Your answer should be compact. -1.72e+06. In the year 1999, what is the difference between the Number of enrolments of both sexes in Bulgaria and Number of enrolments of both sexes in Ghana?
Offer a very short reply. -1.97e+06. In the year 1999, what is the difference between the Number of enrolments of both sexes of Bulgaria and Number of enrolments of both sexes of Palau?
Keep it short and to the point. 4.10e+05. In the year 1999, what is the difference between the Number of enrolments of both sexes of Cambodia and Number of enrolments of both sexes of Ghana?
Provide a succinct answer. -2.50e+05. In the year 1999, what is the difference between the Number of enrolments of both sexes of Cambodia and Number of enrolments of both sexes of Palau?
Provide a succinct answer. 2.13e+06. In the year 1999, what is the difference between the Number of enrolments of both sexes of Ghana and Number of enrolments of both sexes of Palau?
Keep it short and to the point. 2.38e+06. In the year 2000, what is the difference between the Number of enrolments of both sexes of Bulgaria and Number of enrolments of both sexes of Cambodia?
Offer a terse response. -1.86e+06. In the year 2000, what is the difference between the Number of enrolments of both sexes in Bulgaria and Number of enrolments of both sexes in Ghana?
Offer a very short reply. -2.17e+06. In the year 2000, what is the difference between the Number of enrolments of both sexes of Bulgaria and Number of enrolments of both sexes of Palau?
Ensure brevity in your answer.  3.91e+05. In the year 2000, what is the difference between the Number of enrolments of both sexes in Cambodia and Number of enrolments of both sexes in Ghana?
Provide a succinct answer. -3.13e+05. In the year 2000, what is the difference between the Number of enrolments of both sexes in Cambodia and Number of enrolments of both sexes in Palau?
Your response must be concise. 2.25e+06. In the year 2000, what is the difference between the Number of enrolments of both sexes in Ghana and Number of enrolments of both sexes in Palau?
Provide a succinct answer. 2.56e+06. In the year 2003, what is the difference between the Number of enrolments of both sexes in Bulgaria and Number of enrolments of both sexes in Cambodia?
Provide a succinct answer. -2.44e+06. In the year 2003, what is the difference between the Number of enrolments of both sexes in Bulgaria and Number of enrolments of both sexes in Ghana?
Your answer should be very brief. -2.19e+06. In the year 2003, what is the difference between the Number of enrolments of both sexes of Bulgaria and Number of enrolments of both sexes of Palau?
Provide a succinct answer. 3.31e+05. In the year 2003, what is the difference between the Number of enrolments of both sexes of Cambodia and Number of enrolments of both sexes of Ghana?
Your answer should be compact. 2.53e+05. In the year 2003, what is the difference between the Number of enrolments of both sexes of Cambodia and Number of enrolments of both sexes of Palau?
Offer a very short reply. 2.77e+06. In the year 2003, what is the difference between the Number of enrolments of both sexes of Ghana and Number of enrolments of both sexes of Palau?
Ensure brevity in your answer.  2.52e+06. In the year 2004, what is the difference between the Number of enrolments of both sexes of Bulgaria and Number of enrolments of both sexes of Cambodia?
Give a very brief answer. -2.45e+06. In the year 2004, what is the difference between the Number of enrolments of both sexes in Bulgaria and Number of enrolments of both sexes in Ghana?
Keep it short and to the point. -2.36e+06. In the year 2004, what is the difference between the Number of enrolments of both sexes in Bulgaria and Number of enrolments of both sexes in Palau?
Keep it short and to the point. 3.12e+05. In the year 2004, what is the difference between the Number of enrolments of both sexes in Cambodia and Number of enrolments of both sexes in Ghana?
Your answer should be very brief. 8.40e+04. In the year 2004, what is the difference between the Number of enrolments of both sexes of Cambodia and Number of enrolments of both sexes of Palau?
Your answer should be very brief. 2.76e+06. In the year 2004, what is the difference between the Number of enrolments of both sexes of Ghana and Number of enrolments of both sexes of Palau?
Provide a succinct answer. 2.68e+06. In the year 2005, what is the difference between the Number of enrolments of both sexes of Bulgaria and Number of enrolments of both sexes of Cambodia?
Your response must be concise. -2.41e+06. In the year 2005, what is the difference between the Number of enrolments of both sexes of Bulgaria and Number of enrolments of both sexes of Ghana?
Ensure brevity in your answer.  -2.64e+06. In the year 2005, what is the difference between the Number of enrolments of both sexes of Bulgaria and Number of enrolments of both sexes of Palau?
Your response must be concise. 2.88e+05. In the year 2005, what is the difference between the Number of enrolments of both sexes in Cambodia and Number of enrolments of both sexes in Ghana?
Your response must be concise. -2.34e+05. In the year 2005, what is the difference between the Number of enrolments of both sexes in Cambodia and Number of enrolments of both sexes in Palau?
Your answer should be very brief. 2.69e+06. In the year 2005, what is the difference between the Number of enrolments of both sexes of Ghana and Number of enrolments of both sexes of Palau?
Your response must be concise. 2.93e+06. In the year 2006, what is the difference between the Number of enrolments of both sexes in Bulgaria and Number of enrolments of both sexes in Cambodia?
Your response must be concise. -2.31e+06. In the year 2006, what is the difference between the Number of enrolments of both sexes of Bulgaria and Number of enrolments of both sexes of Ghana?
Offer a very short reply. -2.86e+06. In the year 2006, what is the difference between the Number of enrolments of both sexes of Bulgaria and Number of enrolments of both sexes of Palau?
Make the answer very short. 2.71e+05. In the year 2006, what is the difference between the Number of enrolments of both sexes of Cambodia and Number of enrolments of both sexes of Ghana?
Offer a terse response. -5.48e+05. In the year 2006, what is the difference between the Number of enrolments of both sexes in Cambodia and Number of enrolments of both sexes in Palau?
Make the answer very short. 2.58e+06. In the year 2006, what is the difference between the Number of enrolments of both sexes of Ghana and Number of enrolments of both sexes of Palau?
Keep it short and to the point. 3.13e+06. In the year 2007, what is the difference between the Number of enrolments of both sexes of Bulgaria and Number of enrolments of both sexes of Cambodia?
Keep it short and to the point. -2.21e+06. In the year 2007, what is the difference between the Number of enrolments of both sexes of Bulgaria and Number of enrolments of both sexes of Ghana?
Offer a very short reply. -3.10e+06. In the year 2007, what is the difference between the Number of enrolments of both sexes of Bulgaria and Number of enrolments of both sexes of Palau?
Keep it short and to the point. 2.66e+05. In the year 2007, what is the difference between the Number of enrolments of both sexes of Cambodia and Number of enrolments of both sexes of Ghana?
Your response must be concise. -8.88e+05. In the year 2007, what is the difference between the Number of enrolments of both sexes of Cambodia and Number of enrolments of both sexes of Palau?
Provide a short and direct response. 2.48e+06. In the year 2007, what is the difference between the Number of enrolments of both sexes in Ghana and Number of enrolments of both sexes in Palau?
Keep it short and to the point. 3.37e+06. In the year 2013, what is the difference between the Number of enrolments of both sexes of Bulgaria and Number of enrolments of both sexes of Cambodia?
Make the answer very short. -1.97e+06. In the year 2013, what is the difference between the Number of enrolments of both sexes in Bulgaria and Number of enrolments of both sexes in Ghana?
Provide a short and direct response. -3.85e+06. In the year 2013, what is the difference between the Number of enrolments of both sexes in Bulgaria and Number of enrolments of both sexes in Palau?
Make the answer very short. 2.52e+05. In the year 2013, what is the difference between the Number of enrolments of both sexes of Cambodia and Number of enrolments of both sexes of Ghana?
Offer a very short reply. -1.88e+06. In the year 2013, what is the difference between the Number of enrolments of both sexes in Cambodia and Number of enrolments of both sexes in Palau?
Ensure brevity in your answer.  2.22e+06. In the year 2013, what is the difference between the Number of enrolments of both sexes in Ghana and Number of enrolments of both sexes in Palau?
Keep it short and to the point. 4.10e+06. What is the ratio of the Number of enrolments of both sexes in Bulgaria in 1999 to that in 2000?
Your answer should be very brief. 1.05. What is the ratio of the Number of enrolments of both sexes in Cambodia in 1999 to that in 2000?
Your answer should be very brief. 0.95. What is the ratio of the Number of enrolments of both sexes of Ghana in 1999 to that in 2000?
Offer a very short reply. 0.93. What is the ratio of the Number of enrolments of both sexes of Palau in 1999 to that in 2000?
Your answer should be compact. 0.98. What is the ratio of the Number of enrolments of both sexes of Bulgaria in 1999 to that in 2003?
Offer a very short reply. 1.24. What is the ratio of the Number of enrolments of both sexes in Cambodia in 1999 to that in 2003?
Provide a succinct answer. 0.77. What is the ratio of the Number of enrolments of both sexes in Ghana in 1999 to that in 2003?
Ensure brevity in your answer.  0.94. What is the ratio of the Number of enrolments of both sexes in Palau in 1999 to that in 2003?
Your answer should be very brief. 0.96. What is the ratio of the Number of enrolments of both sexes in Bulgaria in 1999 to that in 2004?
Your answer should be very brief. 1.31. What is the ratio of the Number of enrolments of both sexes in Cambodia in 1999 to that in 2004?
Provide a short and direct response. 0.77. What is the ratio of the Number of enrolments of both sexes of Ghana in 1999 to that in 2004?
Your answer should be very brief. 0.89. What is the ratio of the Number of enrolments of both sexes of Palau in 1999 to that in 2004?
Offer a very short reply. 1.02. What is the ratio of the Number of enrolments of both sexes in Bulgaria in 1999 to that in 2005?
Provide a short and direct response. 1.42. What is the ratio of the Number of enrolments of both sexes in Cambodia in 1999 to that in 2005?
Provide a succinct answer. 0.79. What is the ratio of the Number of enrolments of both sexes in Ghana in 1999 to that in 2005?
Offer a terse response. 0.81. What is the ratio of the Number of enrolments of both sexes in Palau in 1999 to that in 2005?
Offer a very short reply. 1.05. What is the ratio of the Number of enrolments of both sexes in Bulgaria in 1999 to that in 2006?
Keep it short and to the point. 1.51. What is the ratio of the Number of enrolments of both sexes of Cambodia in 1999 to that in 2006?
Your answer should be very brief. 0.82. What is the ratio of the Number of enrolments of both sexes of Ghana in 1999 to that in 2006?
Make the answer very short. 0.76. What is the ratio of the Number of enrolments of both sexes in Palau in 1999 to that in 2006?
Your answer should be compact. 1.15. What is the ratio of the Number of enrolments of both sexes of Bulgaria in 1999 to that in 2007?
Keep it short and to the point. 1.54. What is the ratio of the Number of enrolments of both sexes in Cambodia in 1999 to that in 2007?
Offer a terse response. 0.86. What is the ratio of the Number of enrolments of both sexes of Ghana in 1999 to that in 2007?
Your response must be concise. 0.71. What is the ratio of the Number of enrolments of both sexes in Palau in 1999 to that in 2007?
Provide a short and direct response. 1.23. What is the ratio of the Number of enrolments of both sexes in Bulgaria in 1999 to that in 2013?
Your response must be concise. 1.62. What is the ratio of the Number of enrolments of both sexes of Cambodia in 1999 to that in 2013?
Keep it short and to the point. 0.96. What is the ratio of the Number of enrolments of both sexes of Ghana in 1999 to that in 2013?
Keep it short and to the point. 0.58. What is the ratio of the Number of enrolments of both sexes in Palau in 1999 to that in 2013?
Provide a succinct answer. 1.15. What is the ratio of the Number of enrolments of both sexes in Bulgaria in 2000 to that in 2003?
Keep it short and to the point. 1.18. What is the ratio of the Number of enrolments of both sexes in Cambodia in 2000 to that in 2003?
Offer a very short reply. 0.81. What is the ratio of the Number of enrolments of both sexes in Ghana in 2000 to that in 2003?
Your answer should be very brief. 1.02. What is the ratio of the Number of enrolments of both sexes of Palau in 2000 to that in 2003?
Offer a very short reply. 0.98. What is the ratio of the Number of enrolments of both sexes of Bulgaria in 2000 to that in 2004?
Keep it short and to the point. 1.25. What is the ratio of the Number of enrolments of both sexes in Cambodia in 2000 to that in 2004?
Keep it short and to the point. 0.81. What is the ratio of the Number of enrolments of both sexes of Ghana in 2000 to that in 2004?
Make the answer very short. 0.96. What is the ratio of the Number of enrolments of both sexes of Palau in 2000 to that in 2004?
Your answer should be very brief. 1.05. What is the ratio of the Number of enrolments of both sexes of Bulgaria in 2000 to that in 2005?
Keep it short and to the point. 1.35. What is the ratio of the Number of enrolments of both sexes in Cambodia in 2000 to that in 2005?
Your response must be concise. 0.83. What is the ratio of the Number of enrolments of both sexes in Ghana in 2000 to that in 2005?
Provide a succinct answer. 0.87. What is the ratio of the Number of enrolments of both sexes of Palau in 2000 to that in 2005?
Provide a succinct answer. 1.08. What is the ratio of the Number of enrolments of both sexes of Bulgaria in 2000 to that in 2006?
Ensure brevity in your answer.  1.44. What is the ratio of the Number of enrolments of both sexes of Cambodia in 2000 to that in 2006?
Keep it short and to the point. 0.87. What is the ratio of the Number of enrolments of both sexes in Ghana in 2000 to that in 2006?
Provide a succinct answer. 0.82. What is the ratio of the Number of enrolments of both sexes of Palau in 2000 to that in 2006?
Keep it short and to the point. 1.17. What is the ratio of the Number of enrolments of both sexes of Bulgaria in 2000 to that in 2007?
Ensure brevity in your answer.  1.47. What is the ratio of the Number of enrolments of both sexes in Cambodia in 2000 to that in 2007?
Keep it short and to the point. 0.91. What is the ratio of the Number of enrolments of both sexes of Ghana in 2000 to that in 2007?
Offer a very short reply. 0.76. What is the ratio of the Number of enrolments of both sexes of Palau in 2000 to that in 2007?
Make the answer very short. 1.26. What is the ratio of the Number of enrolments of both sexes in Bulgaria in 2000 to that in 2013?
Keep it short and to the point. 1.55. What is the ratio of the Number of enrolments of both sexes of Cambodia in 2000 to that in 2013?
Provide a succinct answer. 1.01. What is the ratio of the Number of enrolments of both sexes in Ghana in 2000 to that in 2013?
Keep it short and to the point. 0.62. What is the ratio of the Number of enrolments of both sexes in Palau in 2000 to that in 2013?
Provide a succinct answer. 1.17. What is the ratio of the Number of enrolments of both sexes in Bulgaria in 2003 to that in 2004?
Give a very brief answer. 1.06. What is the ratio of the Number of enrolments of both sexes of Cambodia in 2003 to that in 2004?
Ensure brevity in your answer.  1. What is the ratio of the Number of enrolments of both sexes of Ghana in 2003 to that in 2004?
Your answer should be compact. 0.94. What is the ratio of the Number of enrolments of both sexes in Palau in 2003 to that in 2004?
Keep it short and to the point. 1.07. What is the ratio of the Number of enrolments of both sexes of Bulgaria in 2003 to that in 2005?
Your response must be concise. 1.15. What is the ratio of the Number of enrolments of both sexes in Cambodia in 2003 to that in 2005?
Provide a short and direct response. 1.03. What is the ratio of the Number of enrolments of both sexes in Ghana in 2003 to that in 2005?
Keep it short and to the point. 0.86. What is the ratio of the Number of enrolments of both sexes of Palau in 2003 to that in 2005?
Offer a terse response. 1.1. What is the ratio of the Number of enrolments of both sexes of Bulgaria in 2003 to that in 2006?
Ensure brevity in your answer.  1.22. What is the ratio of the Number of enrolments of both sexes of Cambodia in 2003 to that in 2006?
Keep it short and to the point. 1.07. What is the ratio of the Number of enrolments of both sexes in Ghana in 2003 to that in 2006?
Offer a terse response. 0.8. What is the ratio of the Number of enrolments of both sexes of Palau in 2003 to that in 2006?
Offer a very short reply. 1.2. What is the ratio of the Number of enrolments of both sexes of Bulgaria in 2003 to that in 2007?
Keep it short and to the point. 1.24. What is the ratio of the Number of enrolments of both sexes of Cambodia in 2003 to that in 2007?
Ensure brevity in your answer.  1.12. What is the ratio of the Number of enrolments of both sexes in Ghana in 2003 to that in 2007?
Your answer should be compact. 0.75. What is the ratio of the Number of enrolments of both sexes of Palau in 2003 to that in 2007?
Give a very brief answer. 1.29. What is the ratio of the Number of enrolments of both sexes of Bulgaria in 2003 to that in 2013?
Provide a succinct answer. 1.31. What is the ratio of the Number of enrolments of both sexes in Cambodia in 2003 to that in 2013?
Provide a short and direct response. 1.25. What is the ratio of the Number of enrolments of both sexes in Ghana in 2003 to that in 2013?
Make the answer very short. 0.61. What is the ratio of the Number of enrolments of both sexes in Palau in 2003 to that in 2013?
Provide a short and direct response. 1.2. What is the ratio of the Number of enrolments of both sexes of Bulgaria in 2004 to that in 2005?
Offer a very short reply. 1.08. What is the ratio of the Number of enrolments of both sexes in Cambodia in 2004 to that in 2005?
Provide a succinct answer. 1.02. What is the ratio of the Number of enrolments of both sexes in Ghana in 2004 to that in 2005?
Your answer should be compact. 0.91. What is the ratio of the Number of enrolments of both sexes in Palau in 2004 to that in 2005?
Your answer should be very brief. 1.03. What is the ratio of the Number of enrolments of both sexes in Bulgaria in 2004 to that in 2006?
Your answer should be very brief. 1.15. What is the ratio of the Number of enrolments of both sexes in Cambodia in 2004 to that in 2006?
Offer a terse response. 1.07. What is the ratio of the Number of enrolments of both sexes in Ghana in 2004 to that in 2006?
Ensure brevity in your answer.  0.86. What is the ratio of the Number of enrolments of both sexes of Palau in 2004 to that in 2006?
Provide a short and direct response. 1.12. What is the ratio of the Number of enrolments of both sexes in Bulgaria in 2004 to that in 2007?
Keep it short and to the point. 1.17. What is the ratio of the Number of enrolments of both sexes of Cambodia in 2004 to that in 2007?
Keep it short and to the point. 1.11. What is the ratio of the Number of enrolments of both sexes in Ghana in 2004 to that in 2007?
Give a very brief answer. 0.8. What is the ratio of the Number of enrolments of both sexes in Palau in 2004 to that in 2007?
Your answer should be compact. 1.2. What is the ratio of the Number of enrolments of both sexes in Bulgaria in 2004 to that in 2013?
Ensure brevity in your answer.  1.24. What is the ratio of the Number of enrolments of both sexes in Cambodia in 2004 to that in 2013?
Ensure brevity in your answer.  1.24. What is the ratio of the Number of enrolments of both sexes of Ghana in 2004 to that in 2013?
Keep it short and to the point. 0.65. What is the ratio of the Number of enrolments of both sexes of Palau in 2004 to that in 2013?
Your response must be concise. 1.12. What is the ratio of the Number of enrolments of both sexes in Bulgaria in 2005 to that in 2006?
Offer a terse response. 1.06. What is the ratio of the Number of enrolments of both sexes of Cambodia in 2005 to that in 2006?
Offer a terse response. 1.04. What is the ratio of the Number of enrolments of both sexes in Ghana in 2005 to that in 2006?
Your answer should be very brief. 0.94. What is the ratio of the Number of enrolments of both sexes in Palau in 2005 to that in 2006?
Offer a terse response. 1.09. What is the ratio of the Number of enrolments of both sexes in Bulgaria in 2005 to that in 2007?
Provide a succinct answer. 1.08. What is the ratio of the Number of enrolments of both sexes of Cambodia in 2005 to that in 2007?
Ensure brevity in your answer.  1.09. What is the ratio of the Number of enrolments of both sexes of Ghana in 2005 to that in 2007?
Provide a succinct answer. 0.87. What is the ratio of the Number of enrolments of both sexes of Palau in 2005 to that in 2007?
Your answer should be very brief. 1.17. What is the ratio of the Number of enrolments of both sexes in Bulgaria in 2005 to that in 2013?
Ensure brevity in your answer.  1.14. What is the ratio of the Number of enrolments of both sexes of Cambodia in 2005 to that in 2013?
Your response must be concise. 1.21. What is the ratio of the Number of enrolments of both sexes in Ghana in 2005 to that in 2013?
Provide a succinct answer. 0.71. What is the ratio of the Number of enrolments of both sexes in Palau in 2005 to that in 2013?
Offer a terse response. 1.09. What is the ratio of the Number of enrolments of both sexes in Bulgaria in 2006 to that in 2007?
Ensure brevity in your answer.  1.02. What is the ratio of the Number of enrolments of both sexes in Cambodia in 2006 to that in 2007?
Provide a succinct answer. 1.04. What is the ratio of the Number of enrolments of both sexes of Ghana in 2006 to that in 2007?
Give a very brief answer. 0.93. What is the ratio of the Number of enrolments of both sexes of Palau in 2006 to that in 2007?
Offer a terse response. 1.07. What is the ratio of the Number of enrolments of both sexes in Bulgaria in 2006 to that in 2013?
Make the answer very short. 1.08. What is the ratio of the Number of enrolments of both sexes in Cambodia in 2006 to that in 2013?
Your answer should be compact. 1.16. What is the ratio of the Number of enrolments of both sexes in Ghana in 2006 to that in 2013?
Make the answer very short. 0.76. What is the ratio of the Number of enrolments of both sexes in Bulgaria in 2007 to that in 2013?
Your answer should be very brief. 1.05. What is the ratio of the Number of enrolments of both sexes in Cambodia in 2007 to that in 2013?
Your answer should be very brief. 1.11. What is the ratio of the Number of enrolments of both sexes of Ghana in 2007 to that in 2013?
Provide a short and direct response. 0.82. What is the ratio of the Number of enrolments of both sexes in Palau in 2007 to that in 2013?
Give a very brief answer. 0.93. What is the difference between the highest and the second highest Number of enrolments of both sexes of Bulgaria?
Your answer should be compact. 1.88e+04. What is the difference between the highest and the second highest Number of enrolments of both sexes in Cambodia?
Keep it short and to the point. 9231. What is the difference between the highest and the second highest Number of enrolments of both sexes of Ghana?
Provide a succinct answer. 7.39e+05. What is the difference between the highest and the second highest Number of enrolments of both sexes in Palau?
Offer a very short reply. 43. What is the difference between the highest and the lowest Number of enrolments of both sexes in Bulgaria?
Ensure brevity in your answer.  1.58e+05. What is the difference between the highest and the lowest Number of enrolments of both sexes of Cambodia?
Give a very brief answer. 6.45e+05. What is the difference between the highest and the lowest Number of enrolments of both sexes in Ghana?
Your answer should be compact. 1.73e+06. What is the difference between the highest and the lowest Number of enrolments of both sexes of Palau?
Provide a succinct answer. 441. 